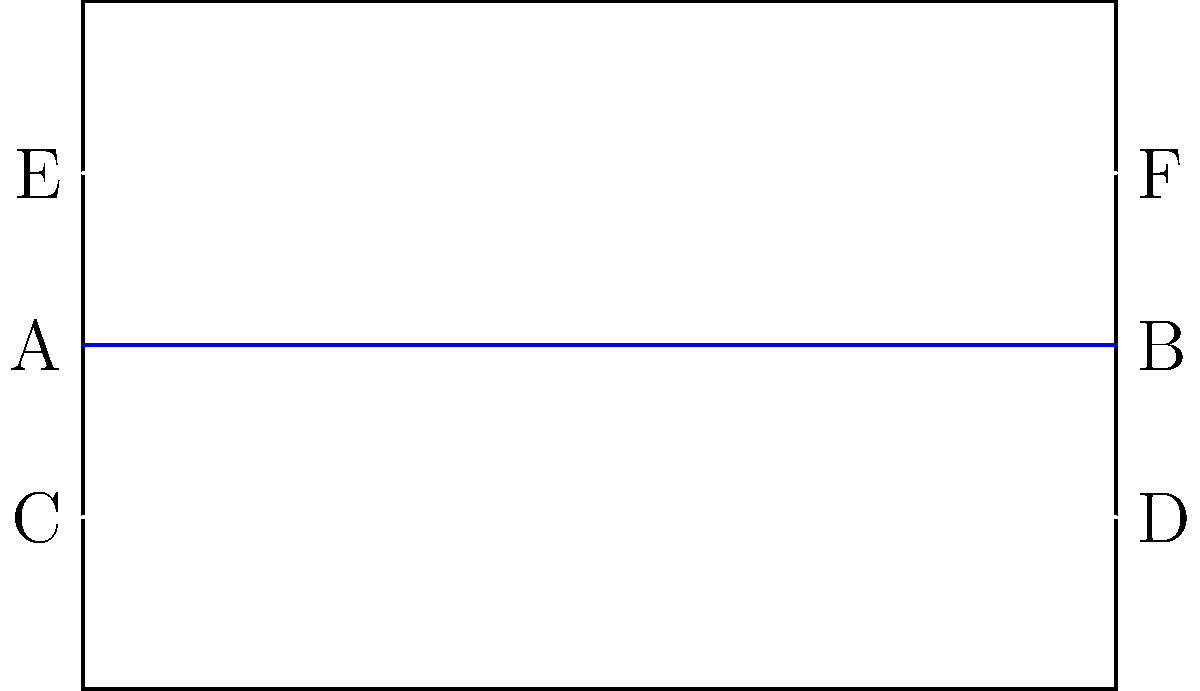As a football commentator in San Marino, you're discussing the national flag during a pre-match analysis. The flag consists of two equal horizontal bands of white (top) and light blue (bottom). Looking at the simplified diagram of the San Marino flag, which pairs of angles formed by the horizontal stripes are congruent? Let's analyze the flag design step-by-step:

1. The flag is represented by a rectangle, which has four right angles (90°) at its corners.

2. The horizontal stripes (blue and white lines) are parallel to the top and bottom edges of the flag.

3. When parallel lines are intersected by another line (in this case, the sides of the flag), corresponding angles are congruent.

4. Let's consider the angles formed at points A, B, C, D, E, and F:
   - Angles at A and B are corresponding angles formed by the blue stripe and the sides of the flag.
   - Angles at C and D are corresponding angles formed by the lower white stripe and the sides of the flag.
   - Angles at E and F are corresponding angles formed by the upper white stripe and the sides of the flag.

5. Due to the properties of corresponding angles, we can conclude that:
   - $\angle$CAE $\cong$ $\angle$DBF
   - $\angle$EAC $\cong$ $\angle$FBD
   - $\angle$ACE $\cong$ $\angle$BDF

Therefore, the congruent pairs of angles are those formed at points (A,B), (C,D), and (E,F).
Answer: (A,B), (C,D), (E,F) 